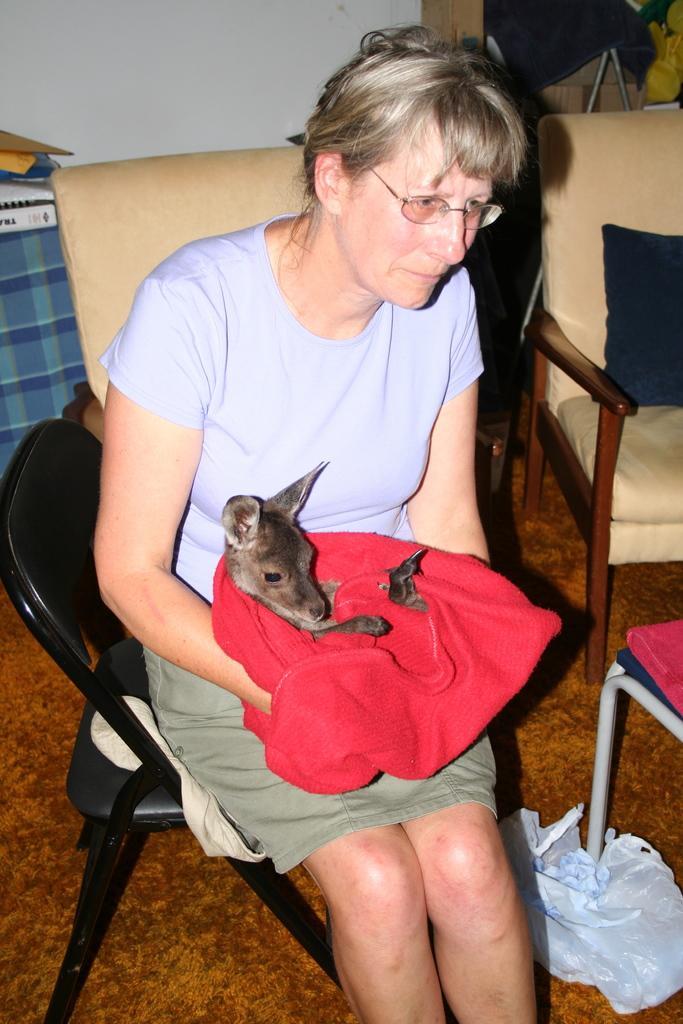Could you give a brief overview of what you see in this image? In this picture we can see an old lady sitting on chair with a puppy in her arms and behind her we can see a couch placed with cushion on it 